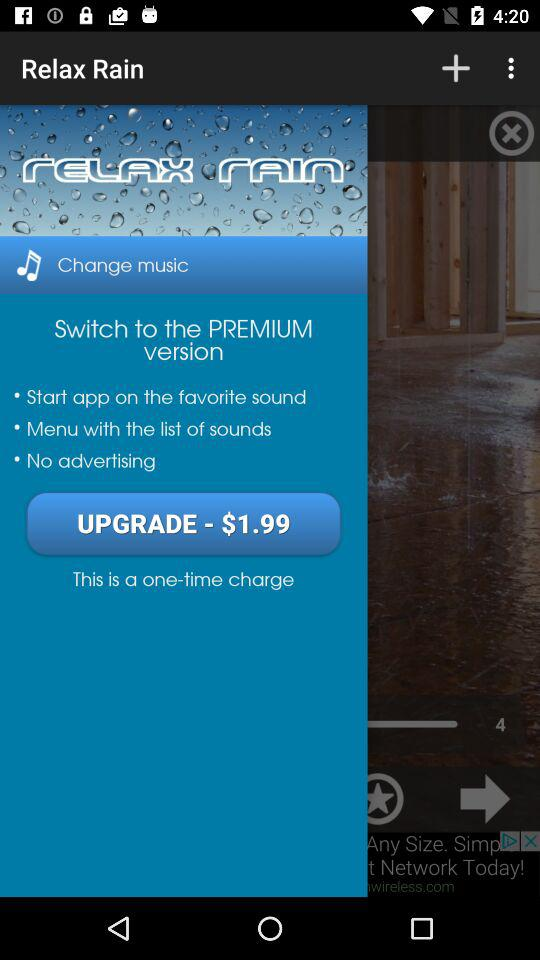What are the upgrade charges to switch to the premium version? The upgrade charge to switch to the premium version is $1.99. 